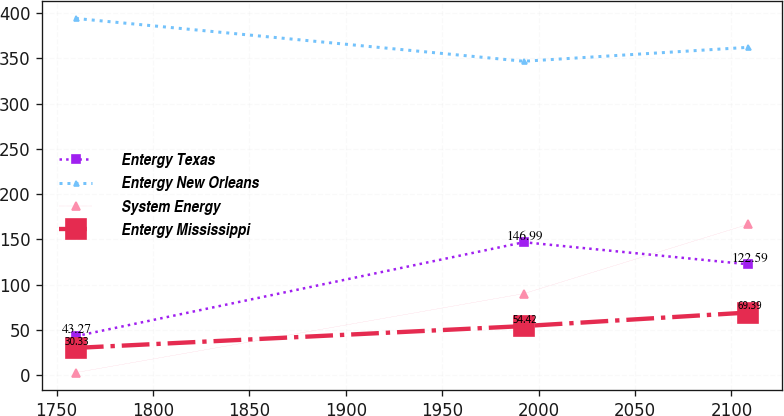Convert chart to OTSL. <chart><loc_0><loc_0><loc_500><loc_500><line_chart><ecel><fcel>Entergy Texas<fcel>Entergy New Orleans<fcel>System Energy<fcel>Entergy Mississippi<nl><fcel>1760.03<fcel>43.27<fcel>393.99<fcel>3.09<fcel>30.33<nl><fcel>1992.38<fcel>146.99<fcel>346.74<fcel>90.25<fcel>54.42<nl><fcel>2108.88<fcel>122.59<fcel>362.14<fcel>166.85<fcel>69.39<nl></chart> 